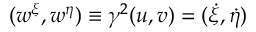Convert formula to latex. <formula><loc_0><loc_0><loc_500><loc_500>( w ^ { \xi } , w ^ { \eta } ) \equiv \gamma ^ { 2 } ( u , v ) = ( \dot { \xi } , \dot { \eta } )</formula> 